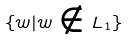<formula> <loc_0><loc_0><loc_500><loc_500>\{ w | w \notin L _ { 1 } \}</formula> 